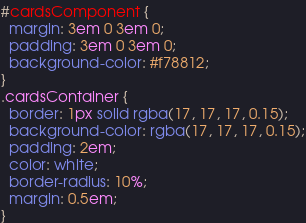Convert code to text. <code><loc_0><loc_0><loc_500><loc_500><_CSS_>#cardsComponent {
  margin: 3em 0 3em 0;
  padding: 3em 0 3em 0;
  background-color: #f78812;
}
.cardsContainer {
  border: 1px solid rgba(17, 17, 17, 0.15);
  background-color: rgba(17, 17, 17, 0.15);
  padding: 2em;
  color: white;
  border-radius: 10%;
  margin: 0.5em;
}
</code> 